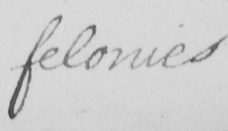Can you read and transcribe this handwriting? felonies 